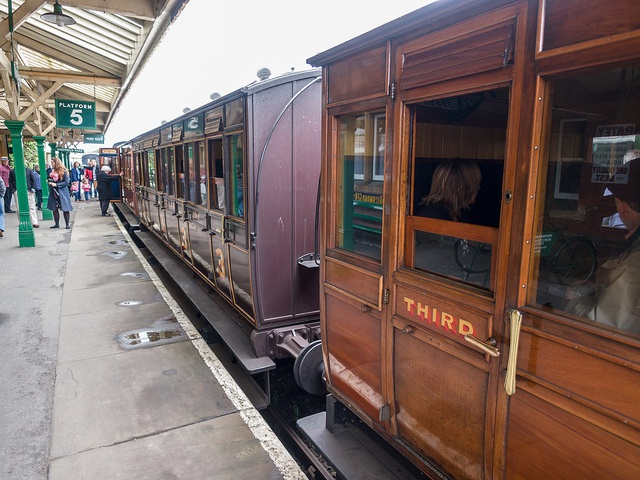Describe the objects in this image and their specific colors. I can see train in white, black, gray, maroon, and brown tones, people in white, black, and gray tones, people in white, black, maroon, and brown tones, people in white, black, gray, and navy tones, and people in white, lightgray, black, darkgray, and navy tones in this image. 